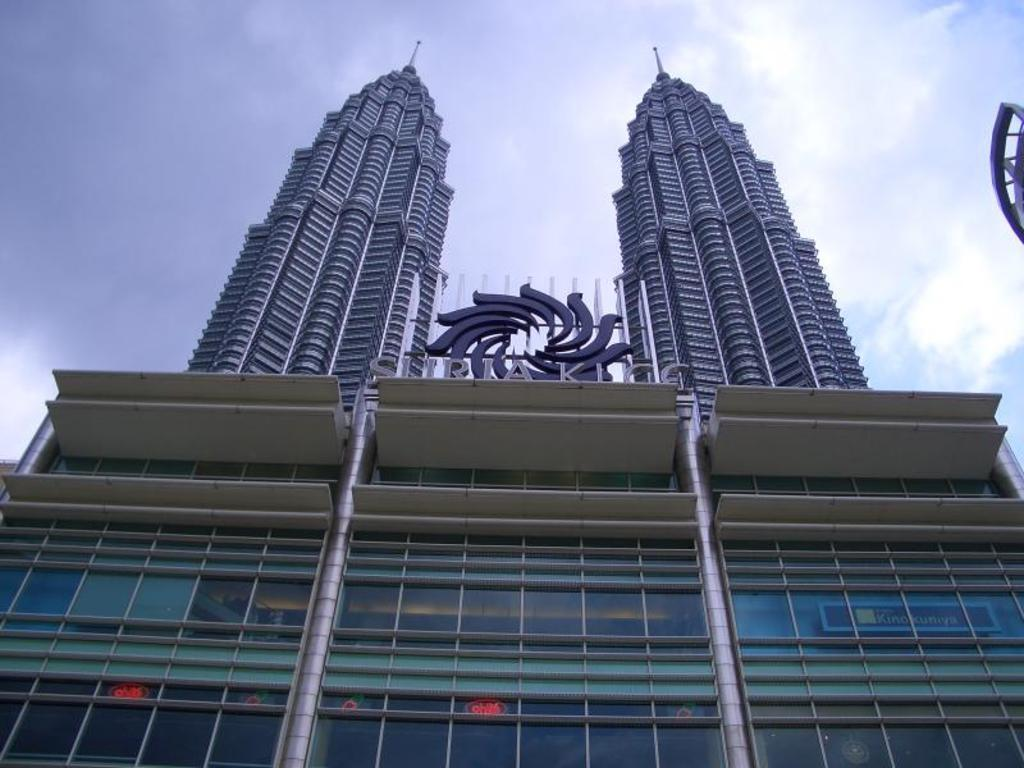What type of structure is present in the picture? There is a building in the picture. What can be seen in the sky above the building? The sky and clouds are visible at the top of the picture. Is there any branding or identification on the building? Yes, there is a logo in the picture. Are there any words or letters in the picture? Yes, there is some text in the picture. What is the purpose of the glasses on the building? The glasses on the building might be for decoration or to serve a functional purpose, such as providing shade or protection. How many clocks are hanging on the walls of the library in the picture? There is no library present in the picture, and therefore no clocks hanging on its walls. What type of fruit is being used as a decoration on the building? There is no fruit present in the picture; the glasses on the building are the only decorative elements mentioned. 